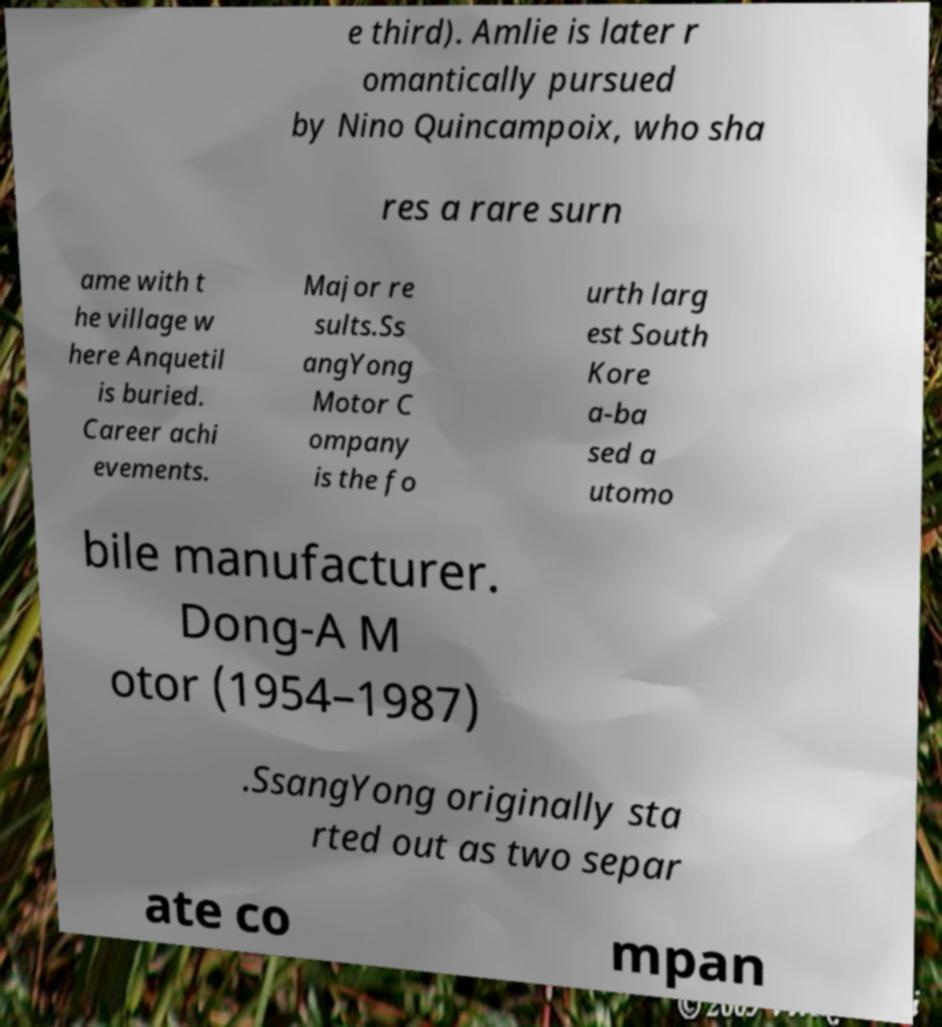Can you accurately transcribe the text from the provided image for me? e third). Amlie is later r omantically pursued by Nino Quincampoix, who sha res a rare surn ame with t he village w here Anquetil is buried. Career achi evements. Major re sults.Ss angYong Motor C ompany is the fo urth larg est South Kore a-ba sed a utomo bile manufacturer. Dong-A M otor (1954–1987) .SsangYong originally sta rted out as two separ ate co mpan 